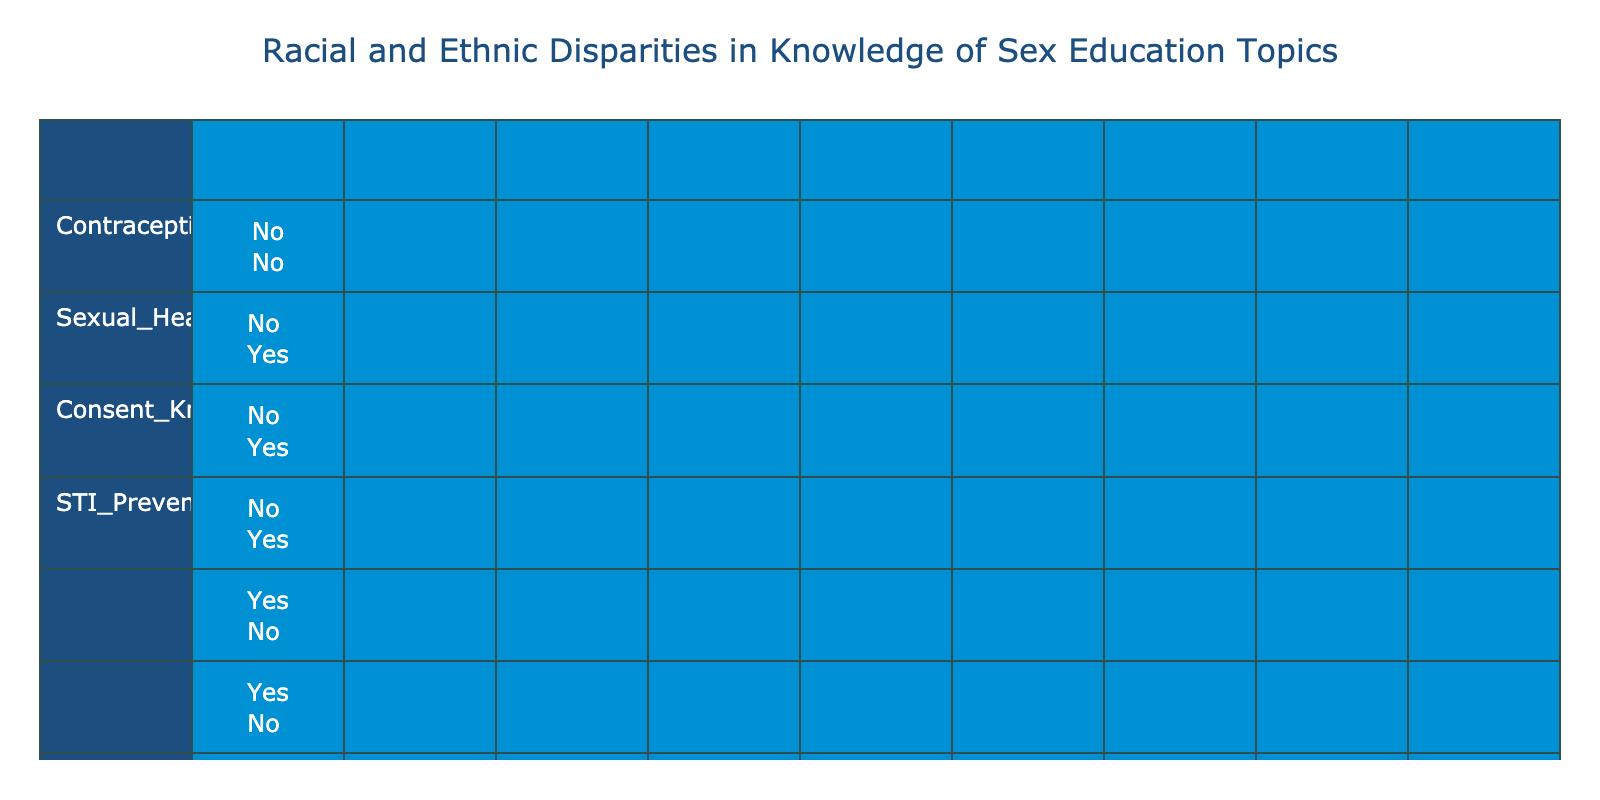What percentage of White students have knowledge of Sexual Health Resources? Looking at the row for White students, there are two instances of knowledge in Sexual Health Resources: Yes and Yes. The corresponding percentages are 100%, so the answer is that 100% of White students have knowledge in this area.
Answer: 100% What is the percentage of Black students who know about STI Prevention? For Black students, there are two entries. In both instances, they know about STI Prevention. Adding those, we see that 100% of Black students are knowledgeable about STI Prevention.
Answer: 100% Among the Multiracial students, what is the knowledge percentage of Consent? The data has one entry for Multiracial students regarding Consent, which indicates Yes. Therefore, the percentage of knowledge for this topic among Multiracial students is 100%.
Answer: 100% What is the difference in Contraception Knowledge between White and Hispanic students? For White students, there are two entries with Yes for Contraception Knowledge, giving 100% knowledge. For Hispanic students, there is only one entry with No, giving 0% knowledge. The difference is 100% - 0% = 100%.
Answer: 100% Are Native American students knowledgeable about Sexual Health Resources? For Native American students, both entries indicate No for Sexual Health Resources knowledge. Thus, they do not have knowledge in this area.
Answer: No What is the average knowledge of Consent among all racial groups in the table? There are five racial categories to consider. The data shows that three groups (White, Black, Multiracial) have knowledge of Consent, while Hispanic and Native American students do not. Therefore, the percentage of knowledge is (3 / 5) * 100 = 60%.
Answer: 60% What percentage of Asian students know about STI prevention? For Asian students, there is one entry indicating knowledge of Yes for STI prevention. Since there is only one data point, the percentage is straightforward: 100%.
Answer: 100% Which racial group shows the least overall knowledge in Sexual Health Resources? Analyzing the data, Native American students have both entries showing No for Sexual Health Resources, leading to 0% knowledge. Therefore, Native American students show the least knowledge in this category.
Answer: Native American students What is the percentage of Hispanic students who know about Contraception? In the dataset, there are two entries for Hispanic students regarding Contraception Knowledge: one showing No and one showing Yes. The overall percentage is based on one Yes and one No, resulting in (1/2) * 100 = 50%.
Answer: 50% 